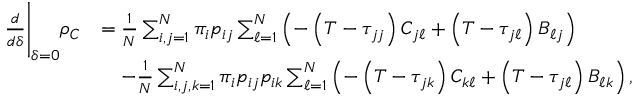Convert formula to latex. <formula><loc_0><loc_0><loc_500><loc_500>\begin{array} { r l } { \frac { d } { d \delta } \Big | _ { \delta = 0 } \rho _ { C } } & { = \frac { 1 } { N } \sum _ { i , j = 1 } ^ { N } \pi _ { i } p _ { i j } \sum _ { \ell = 1 } ^ { N } \left ( - \left ( T - \tau _ { j j } \right ) C _ { j \ell } + \left ( T - \tau _ { j \ell } \right ) B _ { \ell j } \right ) } \\ & { \quad - \frac { 1 } { N } \sum _ { i , j , k = 1 } ^ { N } \pi _ { i } p _ { i j } p _ { i k } \sum _ { \ell = 1 } ^ { N } \left ( - \left ( T - \tau _ { j k } \right ) C _ { k \ell } + \left ( T - \tau _ { j \ell } \right ) B _ { \ell k } \right ) , } \end{array}</formula> 